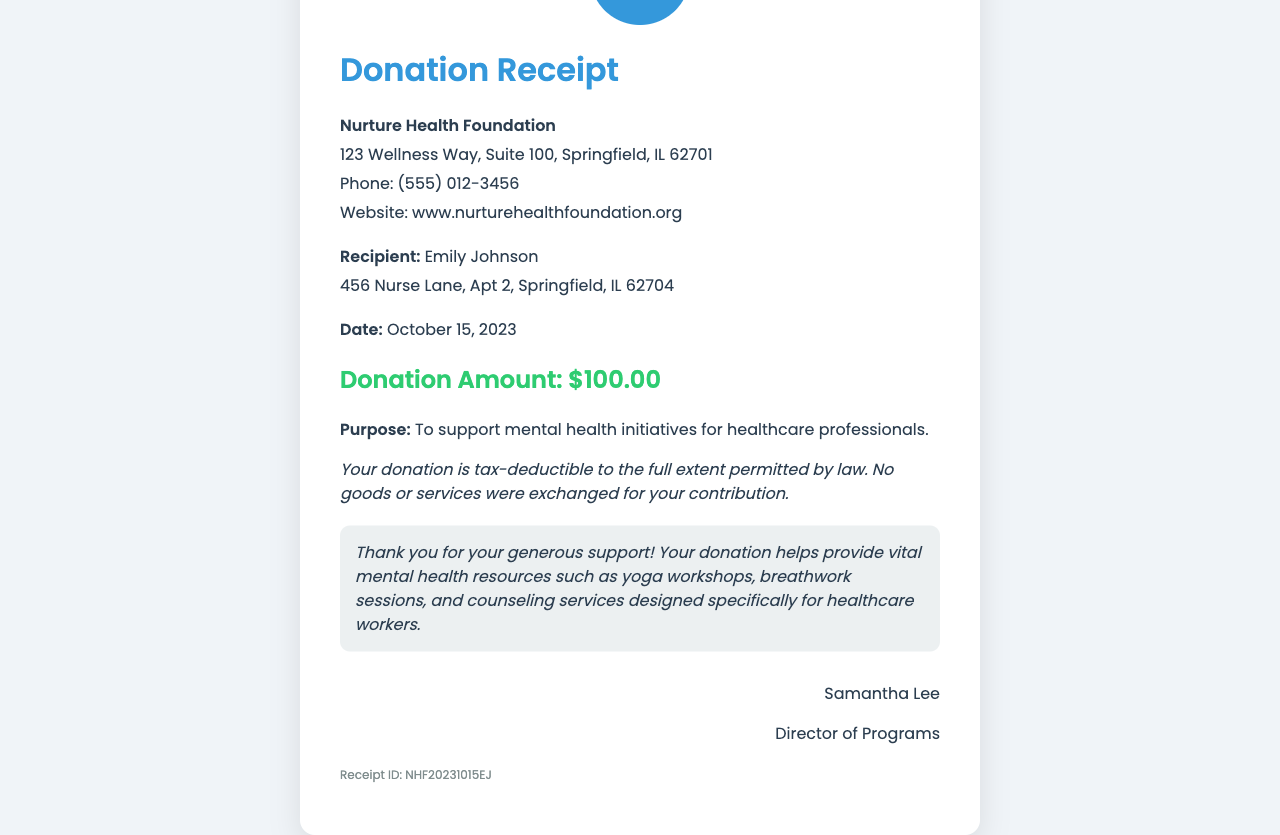What is the name of the foundation? The foundation's name is presented in a prominent position at the top of the receipt.
Answer: Nurture Health Foundation Who is the recipient of the donation? The recipient's name is clearly listed within the details section of the document.
Answer: Emily Johnson What is the donation amount? The donation amount is highlighted in a specific section labeled "Donation Amount."
Answer: $100.00 What is the purpose of the donation? The purpose of the donation is specified below the donation amount in the receipt.
Answer: To support mental health initiatives for healthcare professionals When was the donation made? The date of the donation is stated directly under the recipient information in the document.
Answer: October 15, 2023 Who signed the receipt? The signatory's name is located in the signature section of the receipt.
Answer: Samantha Lee What type of resources does the donation help provide? The message section outlines the resources that the donation supports.
Answer: mental health resources Is the donation tax-deductible? The text close to the bottom of the document highlights the tax status of the donation.
Answer: Yes What is the receipt ID? The receipt ID is mentioned at the bottom of the document as a unique identifier.
Answer: NHF20231015EJ 